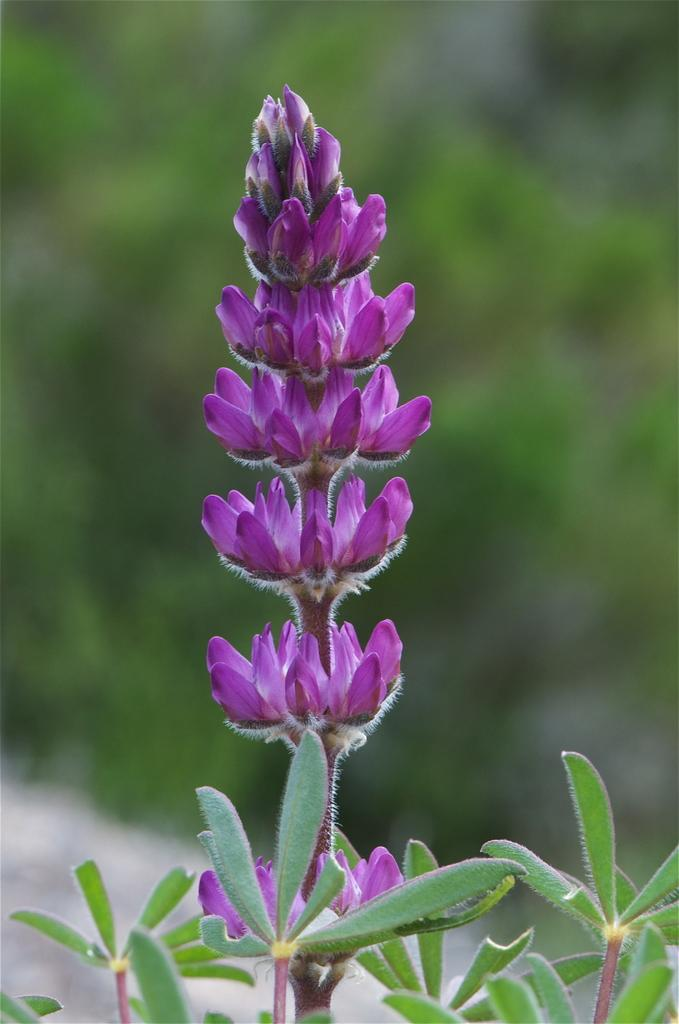What is the main subject of the image? There is a flower in the image. What are the parts of the flower that can be seen? The flower has leaves and stems. How would you describe the background of the image? The background of the image is blurred. What is the flower's desire in the image? The flower does not have desires, as it is a plant and not a living being with emotions or thoughts. 